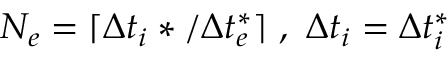<formula> <loc_0><loc_0><loc_500><loc_500>N _ { e } = \lceil \Delta t _ { i } * / \Delta t _ { e } ^ { * } \rceil \ , \ \Delta t _ { i } = \Delta t _ { i } ^ { * }</formula> 